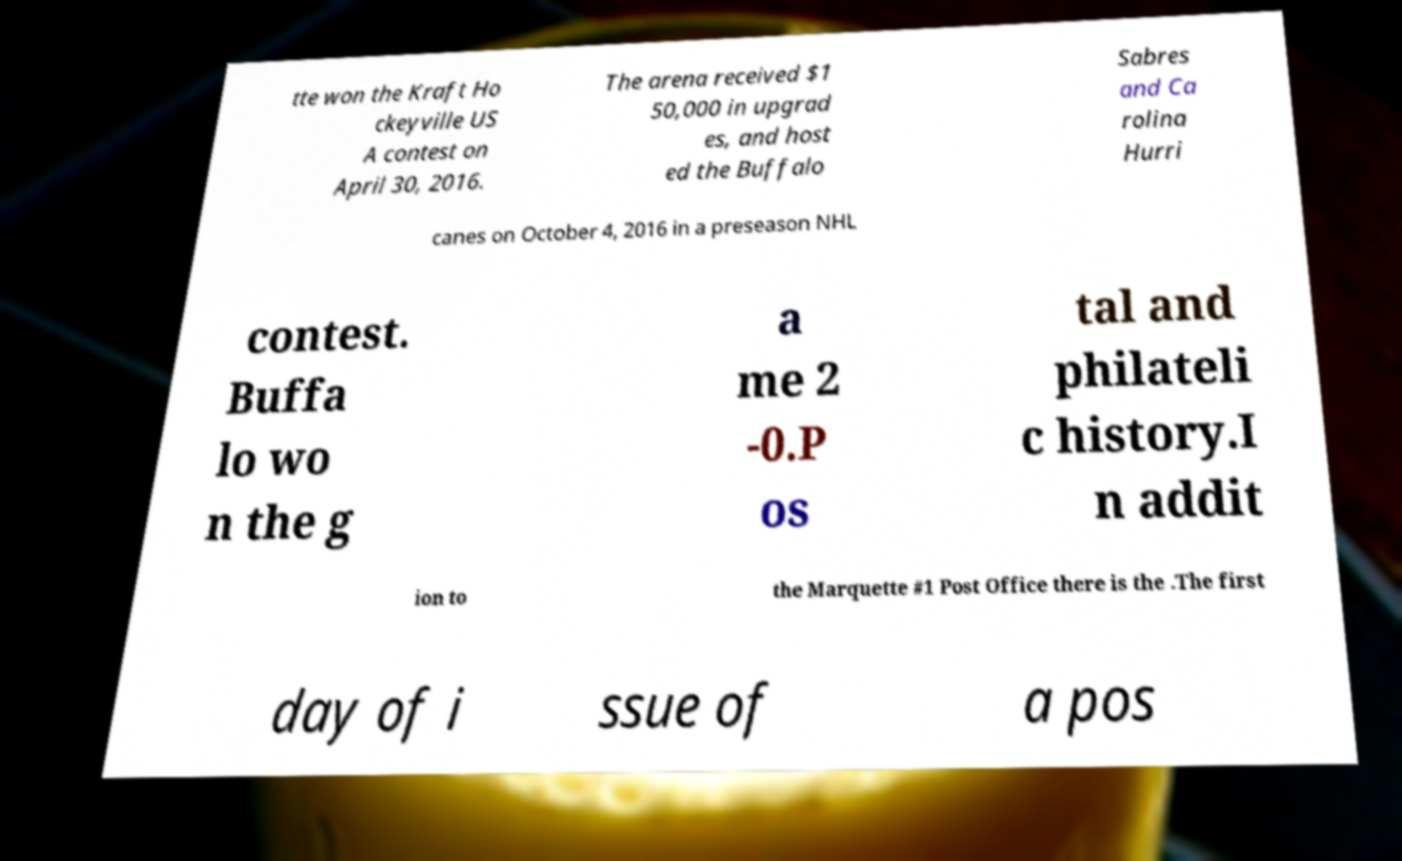There's text embedded in this image that I need extracted. Can you transcribe it verbatim? tte won the Kraft Ho ckeyville US A contest on April 30, 2016. The arena received $1 50,000 in upgrad es, and host ed the Buffalo Sabres and Ca rolina Hurri canes on October 4, 2016 in a preseason NHL contest. Buffa lo wo n the g a me 2 -0.P os tal and philateli c history.I n addit ion to the Marquette #1 Post Office there is the .The first day of i ssue of a pos 